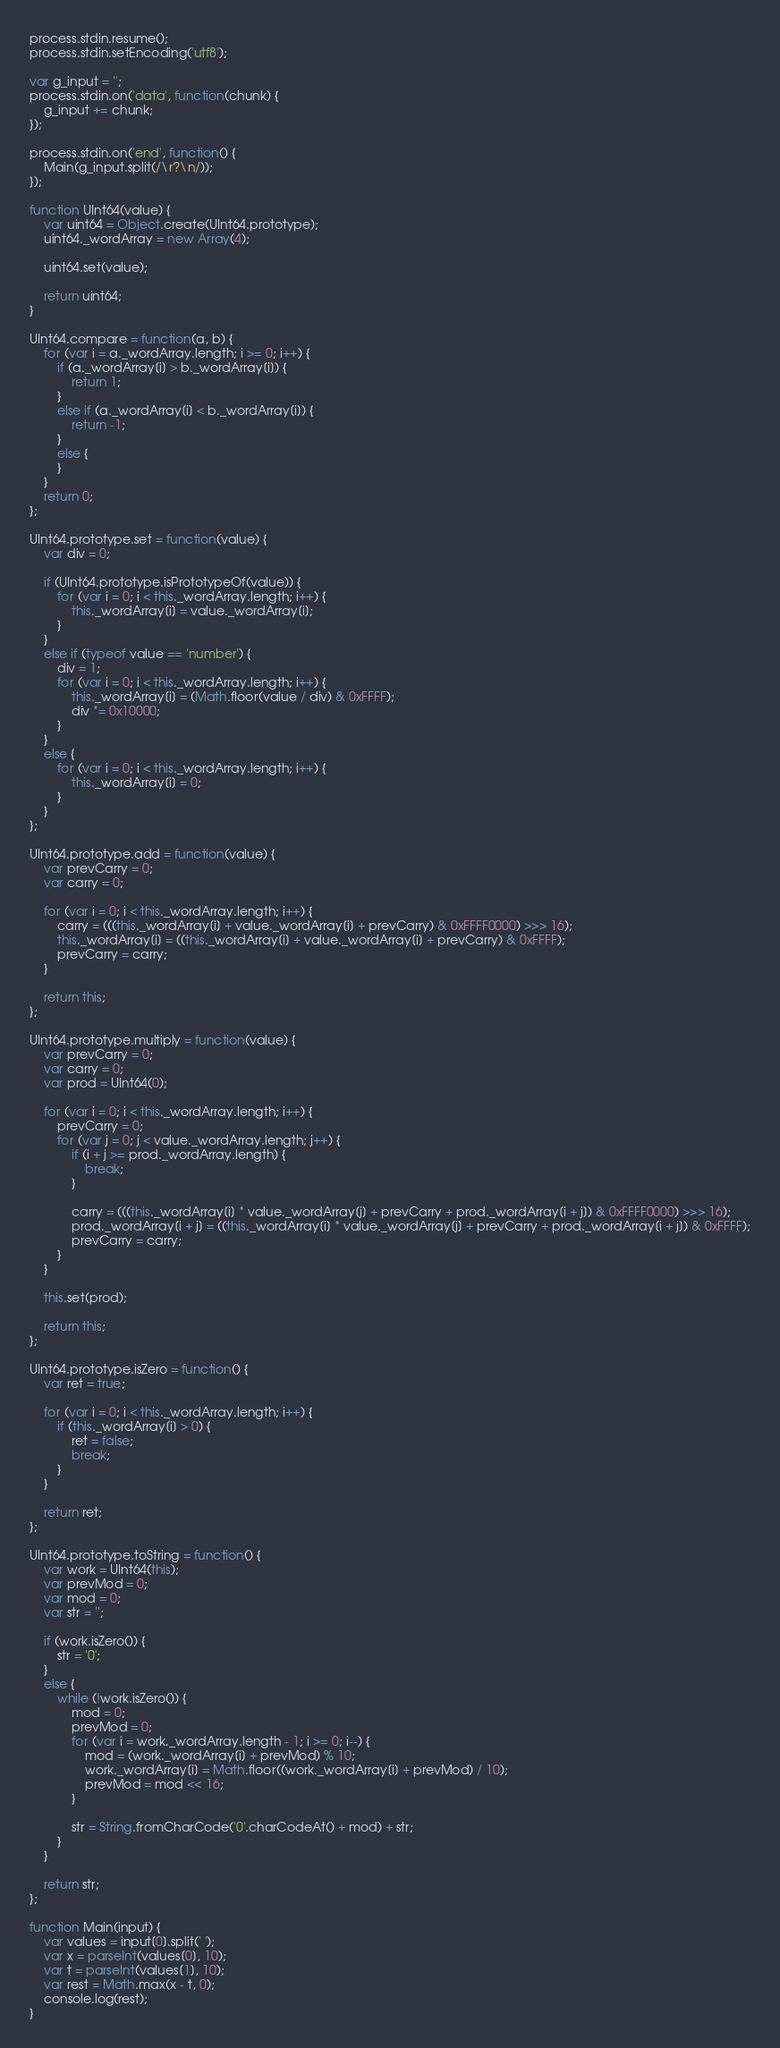<code> <loc_0><loc_0><loc_500><loc_500><_JavaScript_>process.stdin.resume();
process.stdin.setEncoding('utf8');

var g_input = '';
process.stdin.on('data', function(chunk) {
    g_input += chunk;
});

process.stdin.on('end', function() {
    Main(g_input.split(/\r?\n/));
});

function UInt64(value) {
    var uint64 = Object.create(UInt64.prototype);
    uint64._wordArray = new Array(4);

    uint64.set(value);

    return uint64;
}

UInt64.compare = function(a, b) {
    for (var i = a._wordArray.length; i >= 0; i++) {
        if (a._wordArray[i] > b._wordArray[i]) {
            return 1;
        }
        else if (a._wordArray[i] < b._wordArray[i]) {
            return -1;
        }
        else {
        }
    }
    return 0;
};

UInt64.prototype.set = function(value) {
    var div = 0;

    if (UInt64.prototype.isPrototypeOf(value)) {
        for (var i = 0; i < this._wordArray.length; i++) {
            this._wordArray[i] = value._wordArray[i];
        }
    }
    else if (typeof value == 'number') {
        div = 1;
        for (var i = 0; i < this._wordArray.length; i++) {
            this._wordArray[i] = (Math.floor(value / div) & 0xFFFF);
            div *= 0x10000;
        }
    }
    else {
        for (var i = 0; i < this._wordArray.length; i++) {
            this._wordArray[i] = 0;
        }
    }
};

UInt64.prototype.add = function(value) {
    var prevCarry = 0;
    var carry = 0;

    for (var i = 0; i < this._wordArray.length; i++) {
        carry = (((this._wordArray[i] + value._wordArray[i] + prevCarry) & 0xFFFF0000) >>> 16);
        this._wordArray[i] = ((this._wordArray[i] + value._wordArray[i] + prevCarry) & 0xFFFF);
        prevCarry = carry;
    }

    return this;
};

UInt64.prototype.multiply = function(value) {
    var prevCarry = 0;
    var carry = 0;
    var prod = UInt64(0);

    for (var i = 0; i < this._wordArray.length; i++) {
        prevCarry = 0;
        for (var j = 0; j < value._wordArray.length; j++) {
            if (i + j >= prod._wordArray.length) {
                break;
            }

            carry = (((this._wordArray[i] * value._wordArray[j] + prevCarry + prod._wordArray[i + j]) & 0xFFFF0000) >>> 16);
            prod._wordArray[i + j] = ((this._wordArray[i] * value._wordArray[j] + prevCarry + prod._wordArray[i + j]) & 0xFFFF);
            prevCarry = carry;
        }
    }

    this.set(prod);

    return this;
};

UInt64.prototype.isZero = function() {
    var ret = true;

    for (var i = 0; i < this._wordArray.length; i++) {
        if (this._wordArray[i] > 0) {
            ret = false;
            break;
        }
    }

    return ret;
};

UInt64.prototype.toString = function() {
    var work = UInt64(this);
    var prevMod = 0;
    var mod = 0;
    var str = '';

    if (work.isZero()) {
        str = '0';
    }
    else {
        while (!work.isZero()) {
            mod = 0;
            prevMod = 0;
            for (var i = work._wordArray.length - 1; i >= 0; i--) {
                mod = (work._wordArray[i] + prevMod) % 10;
                work._wordArray[i] = Math.floor((work._wordArray[i] + prevMod) / 10);
                prevMod = mod << 16;
            }

            str = String.fromCharCode('0'.charCodeAt() + mod) + str;
        }
    }

    return str;
};

function Main(input) {
    var values = input[0].split(' ');
    var x = parseInt(values[0], 10);
    var t = parseInt(values[1], 10);
    var rest = Math.max(x - t, 0);
    console.log(rest);
}
</code> 